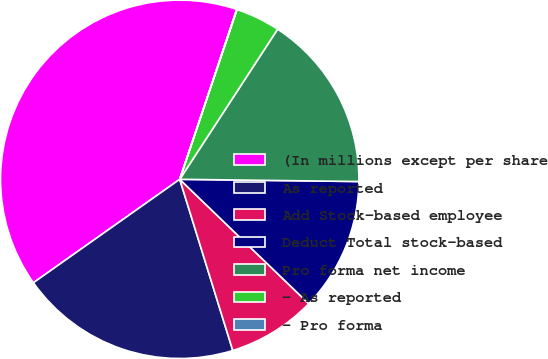<chart> <loc_0><loc_0><loc_500><loc_500><pie_chart><fcel>(In millions except per share<fcel>As reported<fcel>Add Stock-based employee<fcel>Deduct Total stock-based<fcel>Pro forma net income<fcel>- As reported<fcel>- Pro forma<nl><fcel>39.94%<fcel>19.99%<fcel>8.01%<fcel>12.01%<fcel>16.0%<fcel>4.02%<fcel>0.03%<nl></chart> 